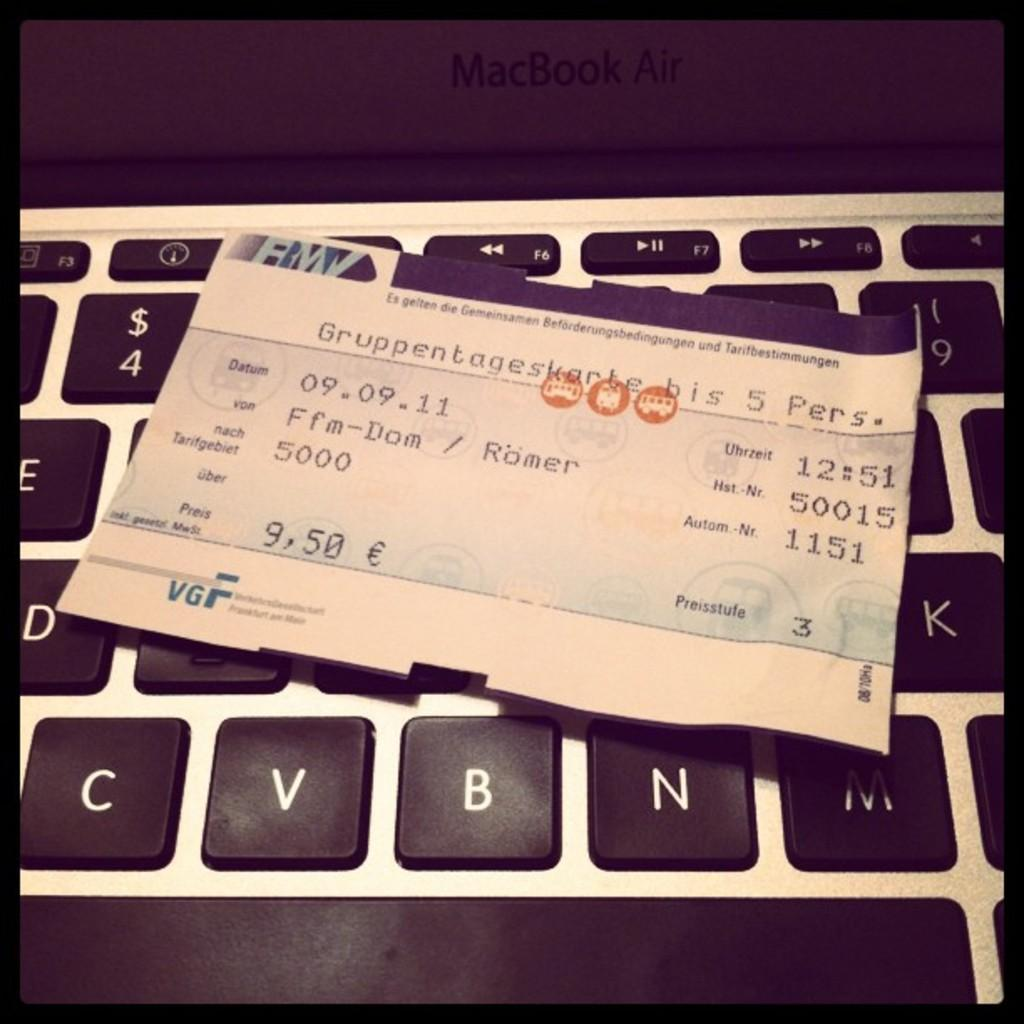Provide a one-sentence caption for the provided image. 9,50 is the total cost displayed on the receipt. 